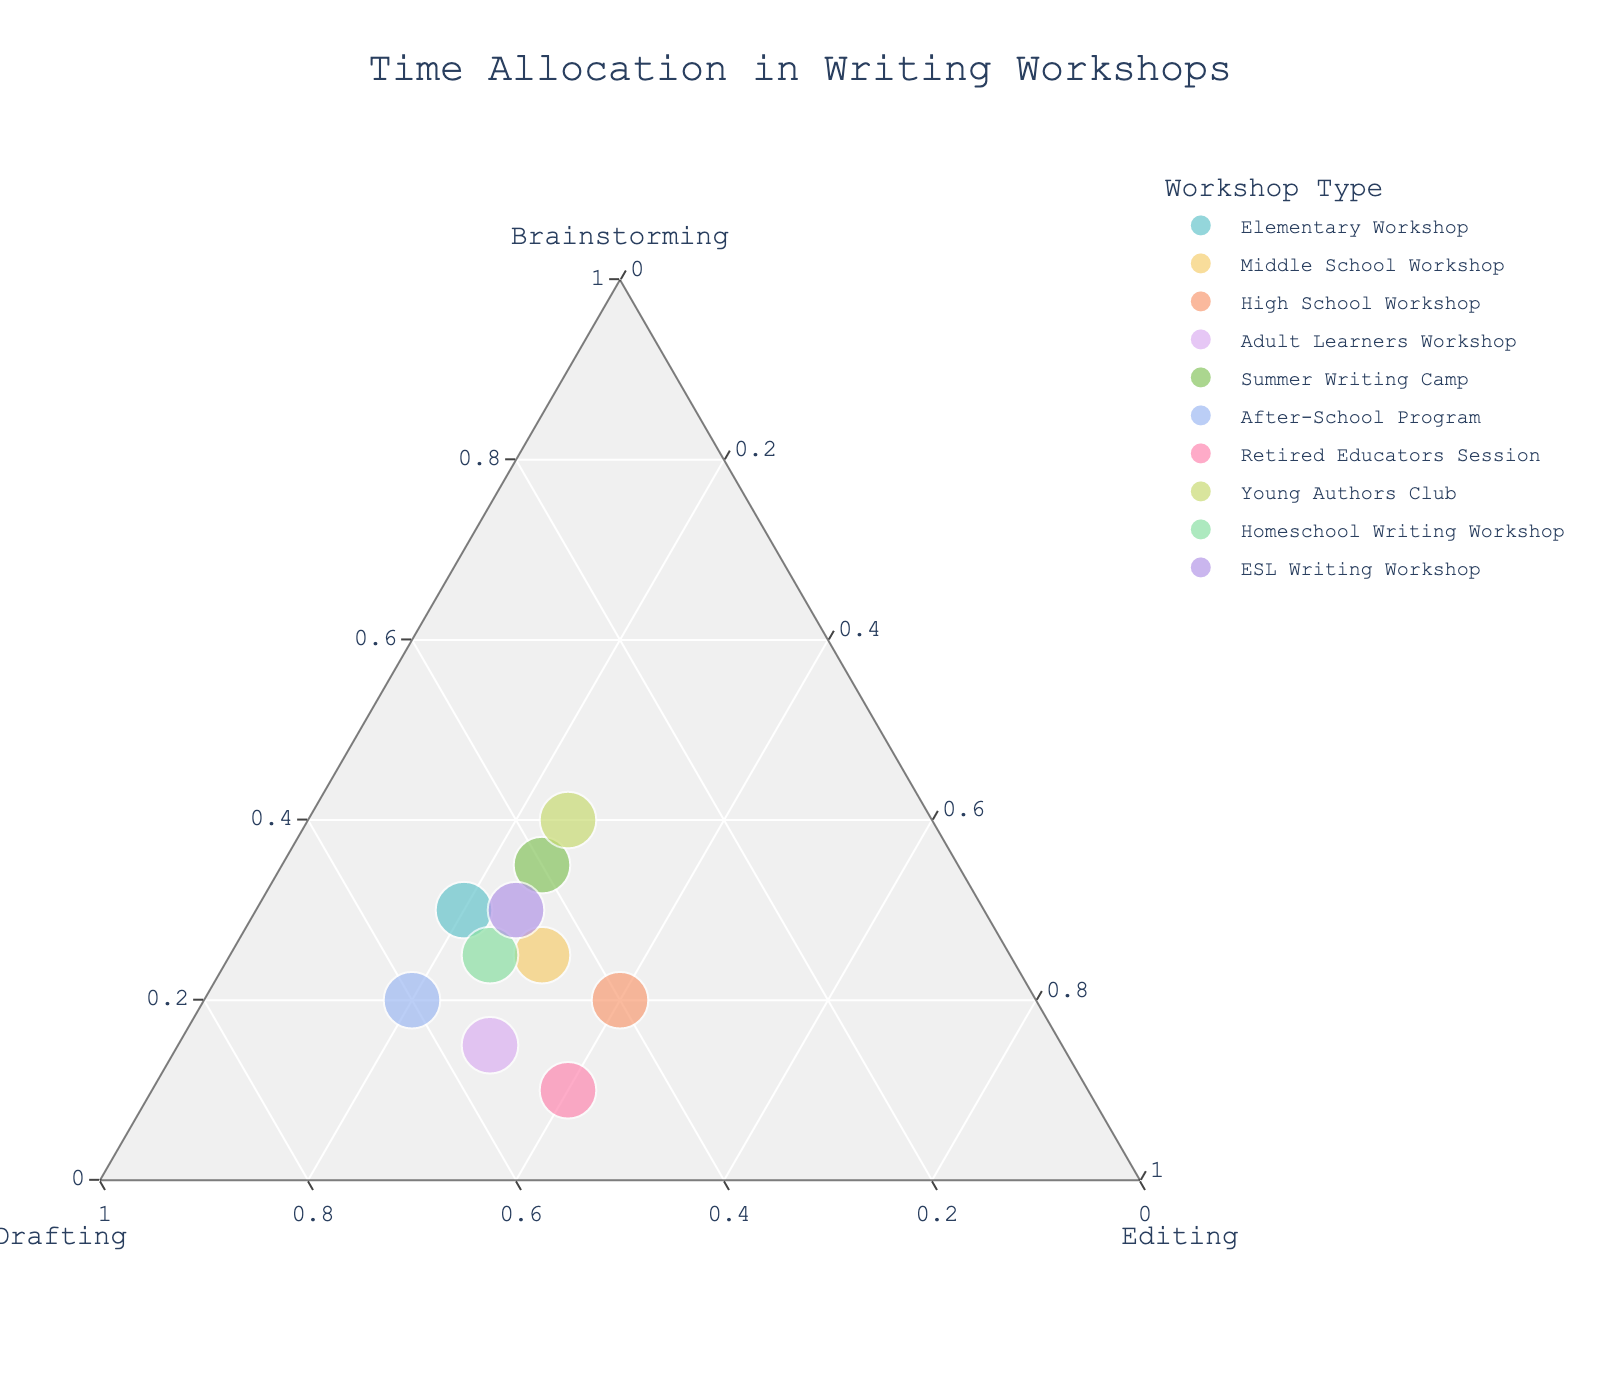How many workshops are represented in the plot? Count the number of data points in the ternary plot based on the number of distinct colors or hover names visible in the plot.
Answer: 10 Which workshop allocates the most time to Brainstorming? Check for the workshop point closest to the Brainstorming corner (apex representing 1 or 100% Brainstorming). Look at the hover text to confirm.
Answer: Young Authors Club Which two workshops allocate the same amount of time to Drafting, and how much time is that? Identify points that have the same distance from the Drafting axis. Hover over the points to read the Drafting percentage.
Answer: After-School Program and Homeschool Writing Workshop, 50% What is the overall trend in allocation of time among Brainstorming, Drafting, and Editing? Observe the distribution of points across the ternary plot. Notice if there are any central tendencies or clustering toward any axis or region, reflecting a balanced approach or preference toward specific activities.
Answer: More balanced with a slight preference towards Drafting Which workshop allocates the least amount of time to Editing? Check for the workshop point closest to the Brainstorming-Drafting axis, furthest from the Editing corner. Check the hover text for confirmation.
Answer: Young Authors Club What is the average percentage time spent on Editing across all workshops? Sum the Editing percentages for all workshops and divide by the total number of workshops. (20+30+40+30+25+20+40+25+25+25)/10 = 280/10
Answer: 28% In which area of the plot are most of the workshops located? Identify the region where the majority of data points are clustered. Look at the central tendencies or specific zones (e.g., close to Drafting, equal distance from all three axes).
Answer: Central region, closer to Drafting Which workshops have identical allocations of time between Brainstorming and Editing? Identify points with equal distances along the Brainstorming and Editing axis. Verify by checking hover text for those points.
Answer: None Between Elementary Workshop and ESL Writing Workshop, which one allocates more time to Drafting? Compare the locations of both workshops' points on the ternary plot, particularly their distances from the Drafting axis.
Answer: Elementary Workshop What proportion of workshops allocate more than 50% of their time to Drafting? Count the workshops with points closer to the Drafting corner of the ternary plot. There are 10 workshops in total; find the number of points with over 50% Drafting from hover text.
Answer: 2 (After-School Program, Adult Learners Workshop) 